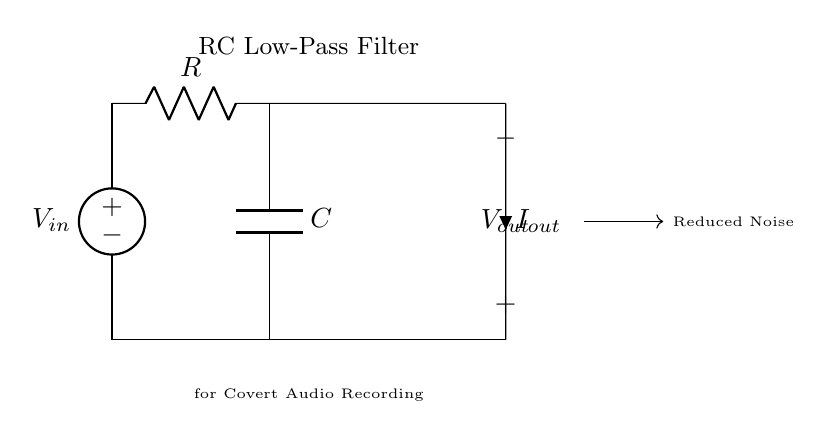What components are in this circuit? The circuit contains a voltage source, a resistor, and a capacitor, which are the main components of an RC low-pass filter.
Answer: voltage source, resistor, capacitor What is the output voltage in relation to the input voltage? In a low-pass filter, the output voltage tends to be lower than the input voltage when high-frequency noise is present; it provides a smoothed output suitable for audio recording.
Answer: lower What is the purpose of the capacitor in this circuit? The capacitor in an RC low-pass filter stores and releases energy, filtering out high-frequency signals and allowing low-frequency signals to pass through.
Answer: filtering How does the resistance value affect the filter's cutoff frequency? The cutoff frequency is inversely related to the resistance; increasing resistance decreases the cutoff frequency, allowing fewer high frequencies through.
Answer: decreases What is the significance of the label "Reduced Noise" in the circuit? The label "Reduced Noise" indicates that the circuit is designed to minimize unwanted high-frequency noise, enhancing the clarity of the recorded audio.
Answer: minimize unwanted noise What would happen if the capacitor were removed from the circuit? Removing the capacitor would result in the circuit no longer functioning as a low-pass filter, allowing all frequencies to pass through without attenuation, including noise.
Answer: no filtering 